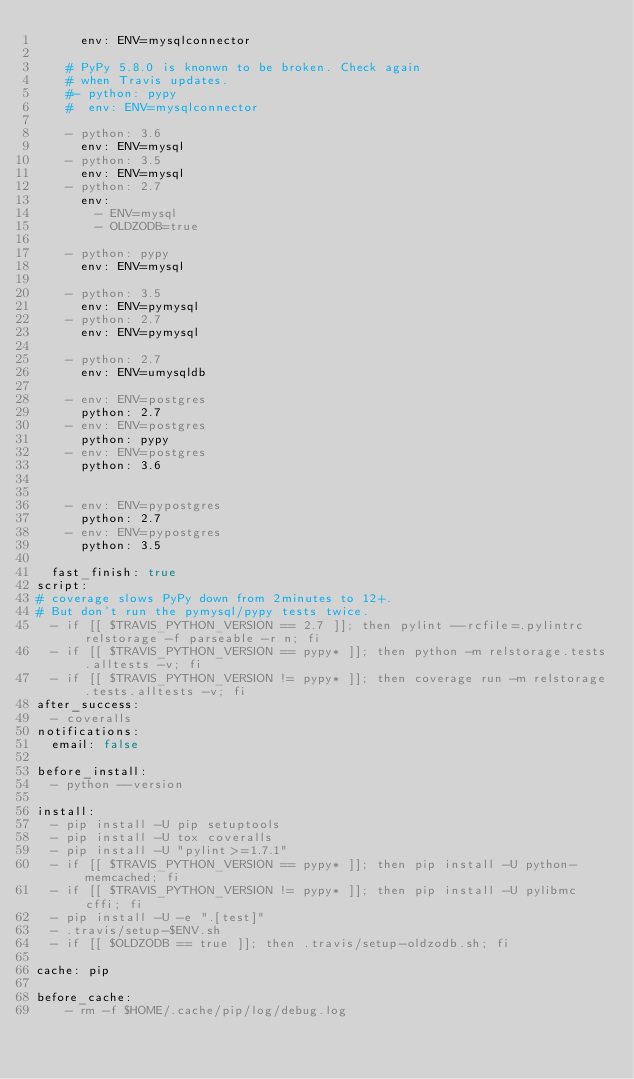<code> <loc_0><loc_0><loc_500><loc_500><_YAML_>      env: ENV=mysqlconnector

    # PyPy 5.8.0 is knonwn to be broken. Check again
    # when Travis updates.
    #- python: pypy
    #  env: ENV=mysqlconnector

    - python: 3.6
      env: ENV=mysql
    - python: 3.5
      env: ENV=mysql
    - python: 2.7
      env:
        - ENV=mysql
        - OLDZODB=true

    - python: pypy
      env: ENV=mysql

    - python: 3.5
      env: ENV=pymysql
    - python: 2.7
      env: ENV=pymysql

    - python: 2.7
      env: ENV=umysqldb

    - env: ENV=postgres
      python: 2.7
    - env: ENV=postgres
      python: pypy
    - env: ENV=postgres
      python: 3.6


    - env: ENV=pypostgres
      python: 2.7
    - env: ENV=pypostgres
      python: 3.5

  fast_finish: true
script:
# coverage slows PyPy down from 2minutes to 12+.
# But don't run the pymysql/pypy tests twice.
  - if [[ $TRAVIS_PYTHON_VERSION == 2.7 ]]; then pylint --rcfile=.pylintrc relstorage -f parseable -r n; fi
  - if [[ $TRAVIS_PYTHON_VERSION == pypy* ]]; then python -m relstorage.tests.alltests -v; fi
  - if [[ $TRAVIS_PYTHON_VERSION != pypy* ]]; then coverage run -m relstorage.tests.alltests -v; fi
after_success:
  - coveralls
notifications:
  email: false

before_install:
  - python --version

install:
  - pip install -U pip setuptools
  - pip install -U tox coveralls
  - pip install -U "pylint>=1.7.1"
  - if [[ $TRAVIS_PYTHON_VERSION == pypy* ]]; then pip install -U python-memcached; fi
  - if [[ $TRAVIS_PYTHON_VERSION != pypy* ]]; then pip install -U pylibmc cffi; fi
  - pip install -U -e ".[test]"
  - .travis/setup-$ENV.sh
  - if [[ $OLDZODB == true ]]; then .travis/setup-oldzodb.sh; fi

cache: pip

before_cache:
    - rm -f $HOME/.cache/pip/log/debug.log
</code> 